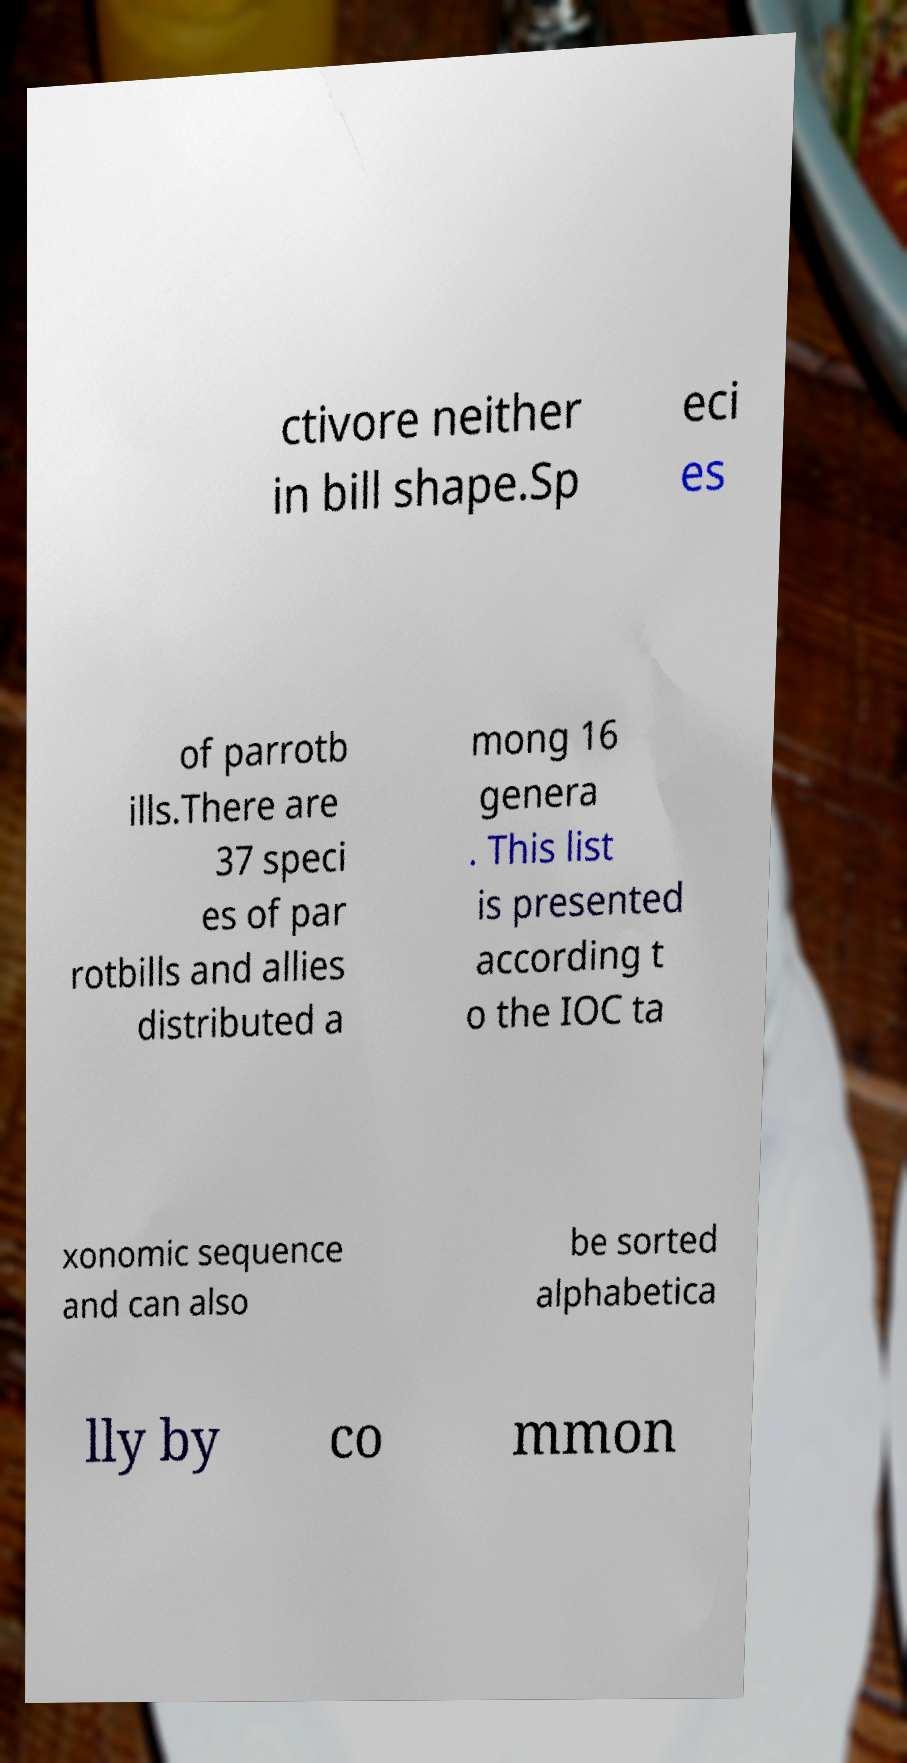I need the written content from this picture converted into text. Can you do that? ctivore neither in bill shape.Sp eci es of parrotb ills.There are 37 speci es of par rotbills and allies distributed a mong 16 genera . This list is presented according t o the IOC ta xonomic sequence and can also be sorted alphabetica lly by co mmon 